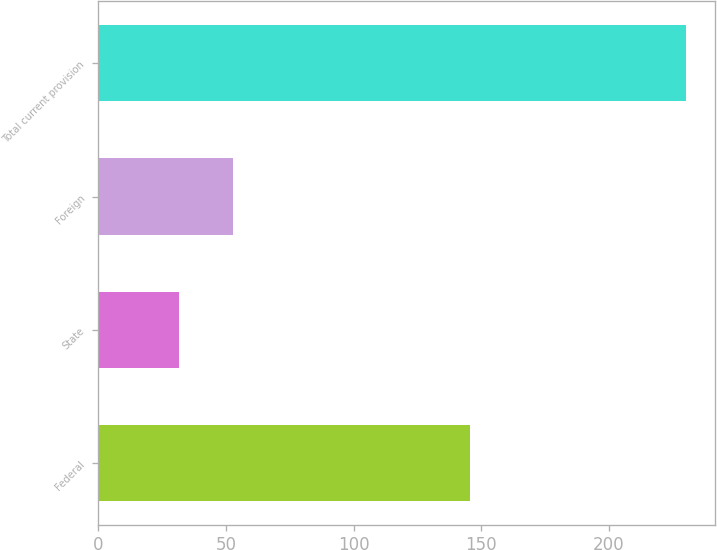<chart> <loc_0><loc_0><loc_500><loc_500><bar_chart><fcel>Federal<fcel>State<fcel>Foreign<fcel>Total current provision<nl><fcel>145.7<fcel>31.7<fcel>52.8<fcel>230.2<nl></chart> 